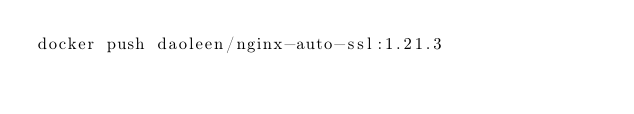Convert code to text. <code><loc_0><loc_0><loc_500><loc_500><_Bash_>docker push daoleen/nginx-auto-ssl:1.21.3</code> 